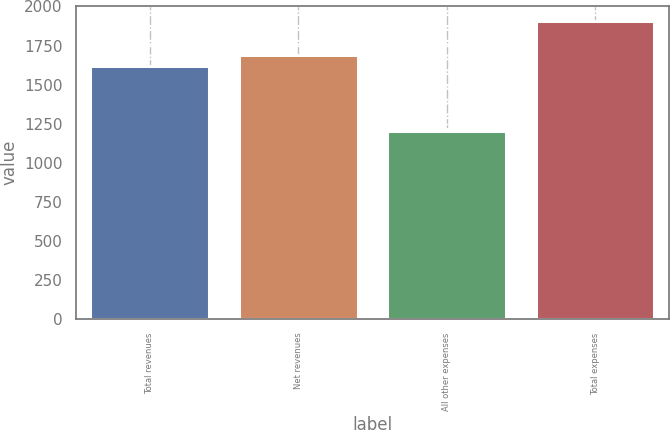Convert chart to OTSL. <chart><loc_0><loc_0><loc_500><loc_500><bar_chart><fcel>Total revenues<fcel>Net revenues<fcel>All other expenses<fcel>Total expenses<nl><fcel>1618<fcel>1688.5<fcel>1200<fcel>1905<nl></chart> 